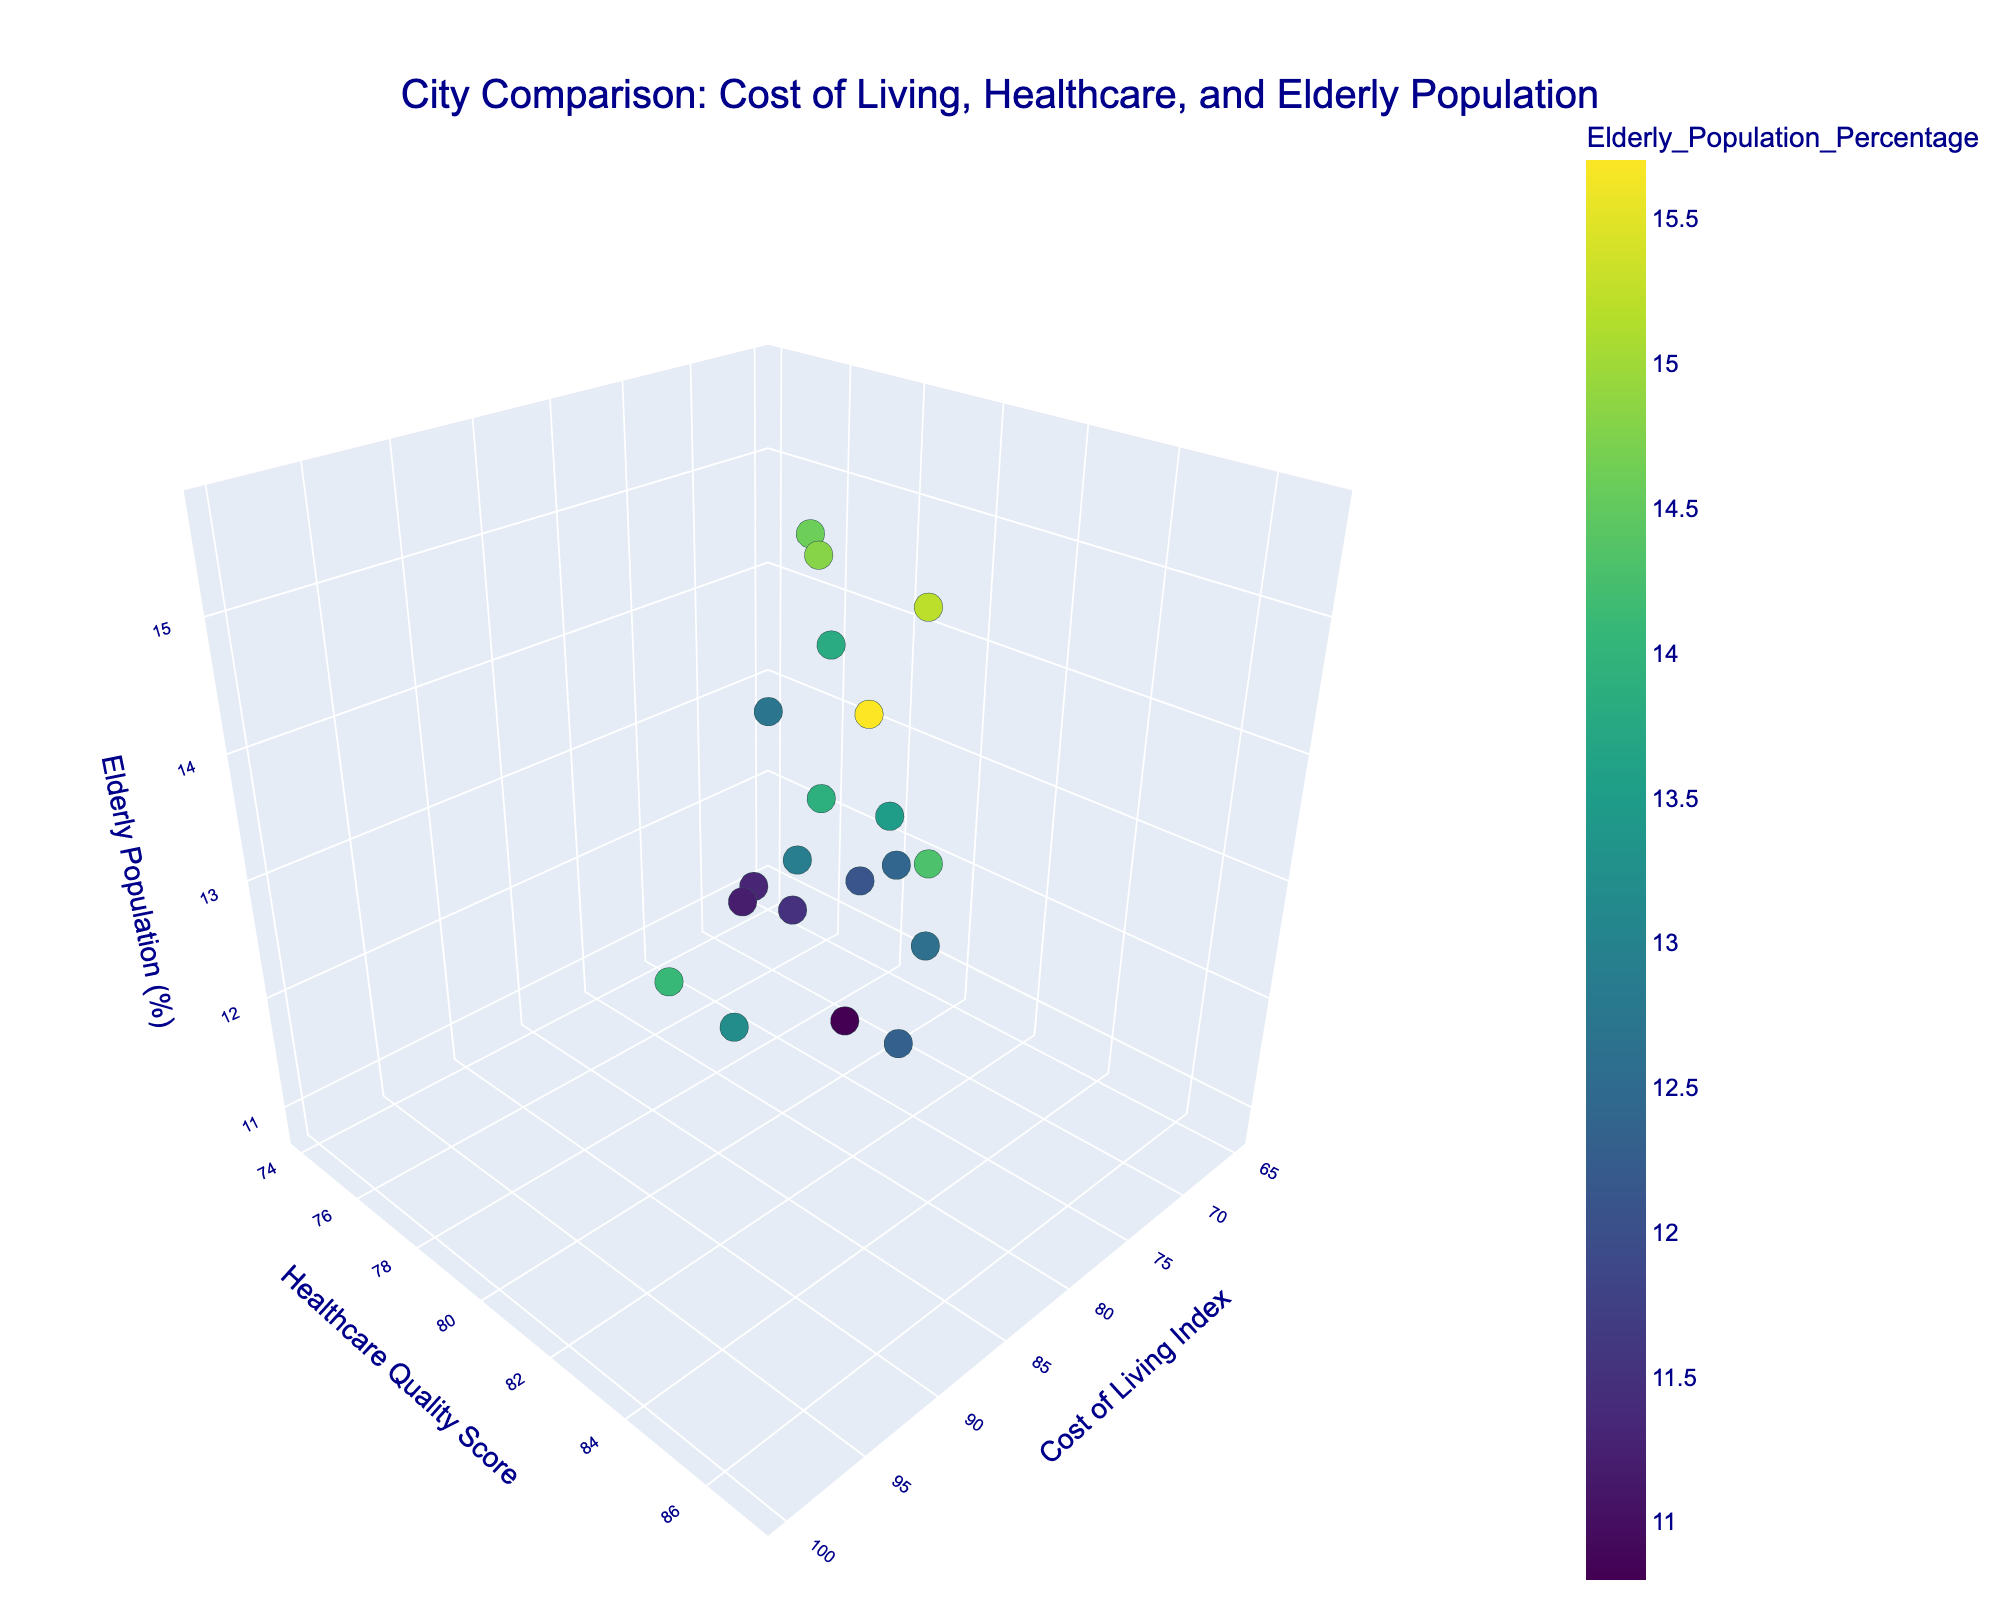What's the title of the figure? The title of the figure is displayed prominently at the top.
Answer: "City Comparison: Cost of Living, Healthcare, and Elderly Population" How many cities have an elderly population percentage greater than 14%? Identify the cities with markers above the 14% mark on the z-axis (Elderly Population Percentage).
Answer: 6 Which city has the highest Healthcare Quality Score? Look for the highest point on the y-axis and find the corresponding city label.
Answer: San Francisco What's the difference in the Cost of Living Index between New York City and Houston? Find the positions of New York City and Houston on the x-axis (Cost of Living Index) and subtract Houston's value from New York City's value.
Answer: 30 Which city has the lowest Cost of Living Index and what is its Healthcare Quality Score? Locate the leftmost point on the x-axis and identify the city's name and its corresponding position on the y-axis.
Answer: San Antonio, 74 Which city has the lowest Healthcare Quality Score, and what's its Elderly Population Percentage? Identify the lowest point on the y-axis and then note its position on the z-axis.
Answer: San Antonio, 12.7 Among the cities with a Cost of Living Index above 80, which one has the highest Elderly Population Percentage? Filter out cities on the graph where the x-axis value is above 80, and then find the highest point on the z-axis among them.
Answer: Philadelphia What's the average Elderly Population Percentage of cities with a Healthcare Quality Score above 80? Identify cities where the y-axis value exceeds 80, sum up their Elderly Population Percentages from the z-axis, and divide by the number of such cities.
Answer: 13.7 Compare Seattle and Washington D.C. in terms of Cost of Living Index and Elderly Population Percentage. Which city has higher values in both attributes? Look at the positions of Seattle and Washington D.C. on the x-axis (Cost of Living Index) and z-axis (Elderly Population Percentage) and compare the values.
Answer: Seattle What pattern do you observe in the Cost of Living Index and Healthcare Quality Score among the top 3 cities with the highest Elderly Population Percentage? Identify the top 3 cities based on the z-axis (Elderly Population Percentage), then observe their positions on the x-axis (Cost of Living Index) and y-axis (Healthcare Quality Score) to infer any patterns.
Answer: Generally high Cost of Living Index and Healthcare Quality Score 